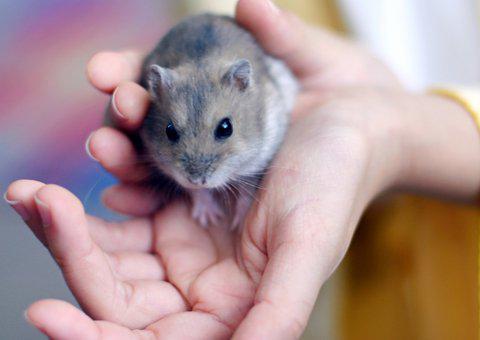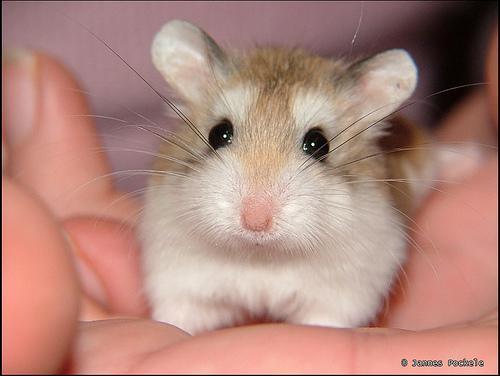The first image is the image on the left, the second image is the image on the right. Given the left and right images, does the statement "At least one hamster is sitting in someone's hand." hold true? Answer yes or no. Yes. 